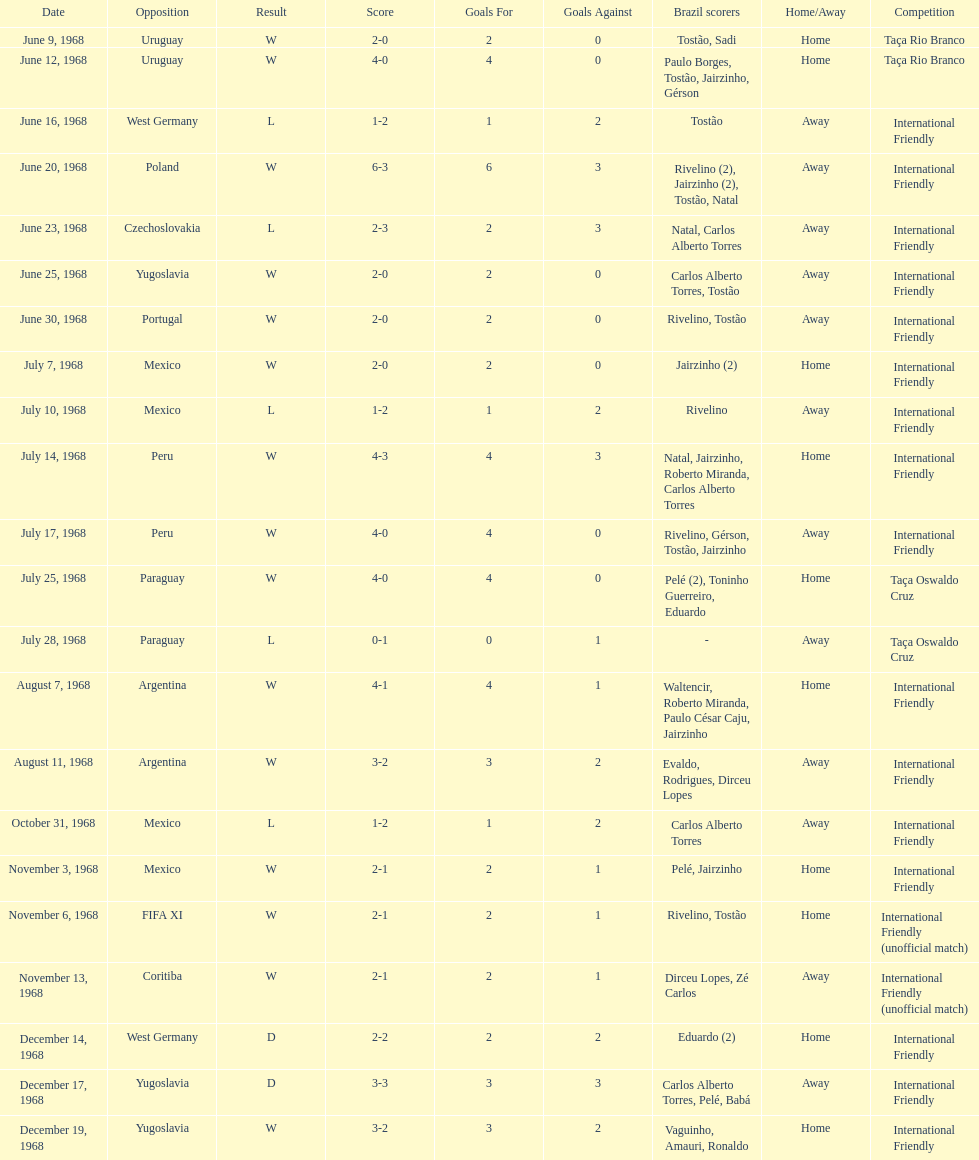Write the full table. {'header': ['Date', 'Opposition', 'Result', 'Score', 'Goals For', 'Goals Against', 'Brazil scorers', 'Home/Away', 'Competition'], 'rows': [['June 9, 1968', 'Uruguay', 'W', '2-0', '2', '0', 'Tostão, Sadi', 'Home', 'Taça Rio Branco'], ['June 12, 1968', 'Uruguay', 'W', '4-0', '4', '0', 'Paulo Borges, Tostão, Jairzinho, Gérson', 'Home', 'Taça Rio Branco'], ['June 16, 1968', 'West Germany', 'L', '1-2', '1', '2', 'Tostão', 'Away', 'International Friendly'], ['June 20, 1968', 'Poland', 'W', '6-3', '6', '3', 'Rivelino (2), Jairzinho (2), Tostão, Natal', 'Away', 'International Friendly'], ['June 23, 1968', 'Czechoslovakia', 'L', '2-3', '2', '3', 'Natal, Carlos Alberto Torres', 'Away', 'International Friendly'], ['June 25, 1968', 'Yugoslavia', 'W', '2-0', '2', '0', 'Carlos Alberto Torres, Tostão', 'Away', 'International Friendly'], ['June 30, 1968', 'Portugal', 'W', '2-0', '2', '0', 'Rivelino, Tostão', 'Away', 'International Friendly'], ['July 7, 1968', 'Mexico', 'W', '2-0', '2', '0', 'Jairzinho (2)', 'Home', 'International Friendly'], ['July 10, 1968', 'Mexico', 'L', '1-2', '1', '2', 'Rivelino', 'Away', 'International Friendly'], ['July 14, 1968', 'Peru', 'W', '4-3', '4', '3', 'Natal, Jairzinho, Roberto Miranda, Carlos Alberto Torres', 'Home', 'International Friendly'], ['July 17, 1968', 'Peru', 'W', '4-0', '4', '0', 'Rivelino, Gérson, Tostão, Jairzinho', 'Away', 'International Friendly'], ['July 25, 1968', 'Paraguay', 'W', '4-0', '4', '0', 'Pelé (2), Toninho Guerreiro, Eduardo', 'Home', 'Taça Oswaldo Cruz'], ['July 28, 1968', 'Paraguay', 'L', '0-1', '0', '1', '-', 'Away', 'Taça Oswaldo Cruz'], ['August 7, 1968', 'Argentina', 'W', '4-1', '4', '1', 'Waltencir, Roberto Miranda, Paulo César Caju, Jairzinho', 'Home', 'International Friendly'], ['August 11, 1968', 'Argentina', 'W', '3-2', '3', '2', 'Evaldo, Rodrigues, Dirceu Lopes', 'Away', 'International Friendly'], ['October 31, 1968', 'Mexico', 'L', '1-2', '1', '2', 'Carlos Alberto Torres', 'Away', 'International Friendly'], ['November 3, 1968', 'Mexico', 'W', '2-1', '2', '1', 'Pelé, Jairzinho', 'Home', 'International Friendly'], ['November 6, 1968', 'FIFA XI', 'W', '2-1', '2', '1', 'Rivelino, Tostão', 'Home', 'International Friendly (unofficial match)'], ['November 13, 1968', 'Coritiba', 'W', '2-1', '2', '1', 'Dirceu Lopes, Zé Carlos', 'Away', 'International Friendly (unofficial match)'], ['December 14, 1968', 'West Germany', 'D', '2-2', '2', '2', 'Eduardo (2)', 'Home', 'International Friendly'], ['December 17, 1968', 'Yugoslavia', 'D', '3-3', '3', '3', 'Carlos Alberto Torres, Pelé, Babá', 'Away', 'International Friendly'], ['December 19, 1968', 'Yugoslavia', 'W', '3-2', '3', '2', 'Vaguinho, Amauri, Ronaldo', 'Home', 'International Friendly']]} What is the top score ever scored by the brazil national team? 6. 